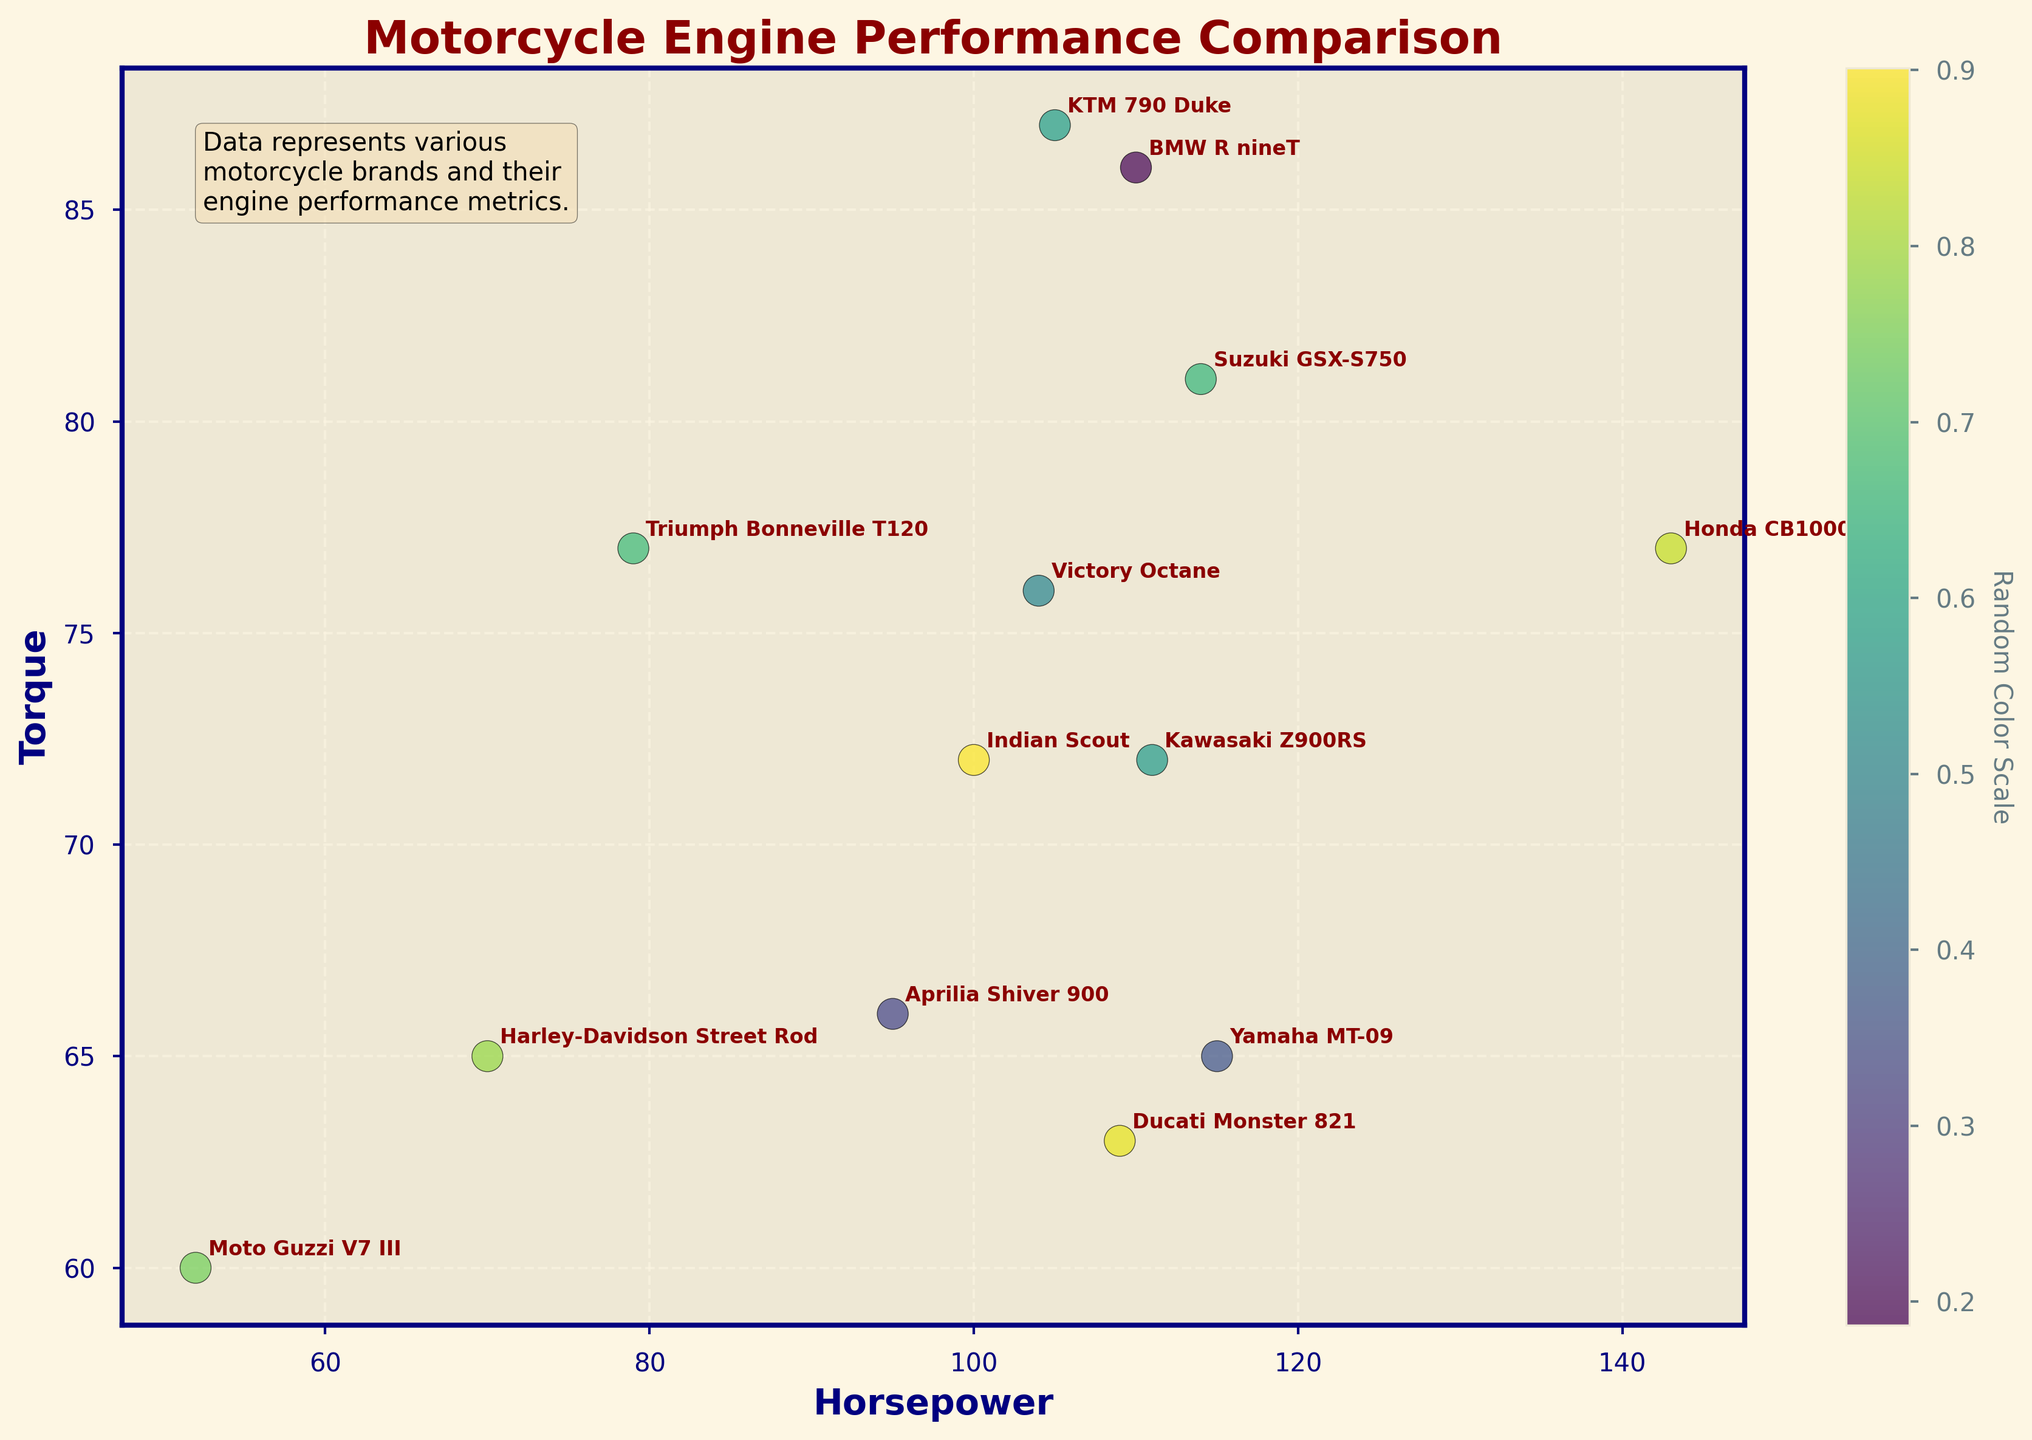How many data points are there in the figure? The figure contains a total of 13 data points, each representing a different motorcycle brand. By counting the number of unique points or brand names, we arrive at this number.
Answer: 13 Which motorcycle brand has the highest horsepower? By locating the point farthest along the x-axis (Horsepower) in the plot, we see the "Honda CB1000R" has the highest horsepower.
Answer: Honda CB1000R What is the title of the plot? The title of the plot is written at the top of the figure, clearly indicating its purpose.
Answer: Motorcycle Engine Performance Comparison Which motorcycle brand stands out with the highest torque? By locating the point farthest along the y-axis (Torque) in the plot, we observe that the "KTM 790 Duke" has the highest torque.
Answer: KTM 790 Duke What is the horsepower range covered by the different motorcycle brands? By observing the spread of the points along the x-axis, the minimum horsepower is 52 (Moto Guzzi V7 III) and the maximum is 143 (Honda CB1000R), therefore the range is 143 - 52.
Answer: 91 Name two motorcycle brands that have similar performance with roughly the same horsepower and torque. By identifying points that are close to each other, "Harley-Davidson Street Rod" and "Yamaha MT-09" both have similar horsepower and torque values in the plot.
Answer: Harley-Davidson Street Rod, Yamaha MT-09 Among "Harley-Davidson Street Rod" and "Indian Scout," which one has higher torque? By directly comparing their y-coordinates, "Indian Scout" (72) has a higher torque value than "Harley-Davidson Street Rod" (65).
Answer: Indian Scout Which brand is represented by the point with the lowest horsepower and lowest torque? The point at the lower left corner of the plot signifies the data point with the minimum x (Horsepower) and y (Torque) values, which is "Moto Guzzi V7 III."
Answer: Moto Guzzi V7 III What's the average torque of the motorcycles shown in the plot? To get the average, sum all the torque values (65 + 72 + 77 + 63 + 86 + 65 + 72 + 60 + 77 + 81 + 87 + 66 + 76) and divide by the number of brands (13). The calculation is (947 / 13).
Answer: 72.85 Which brand occupies a middle position on the plot in terms of both horsepower and torque? By locating the central scatter of points on the plot, "Aprilia Shiver 900" appears to be in the middle in terms of both horsepower and torque.
Answer: Aprilia Shiver 900 